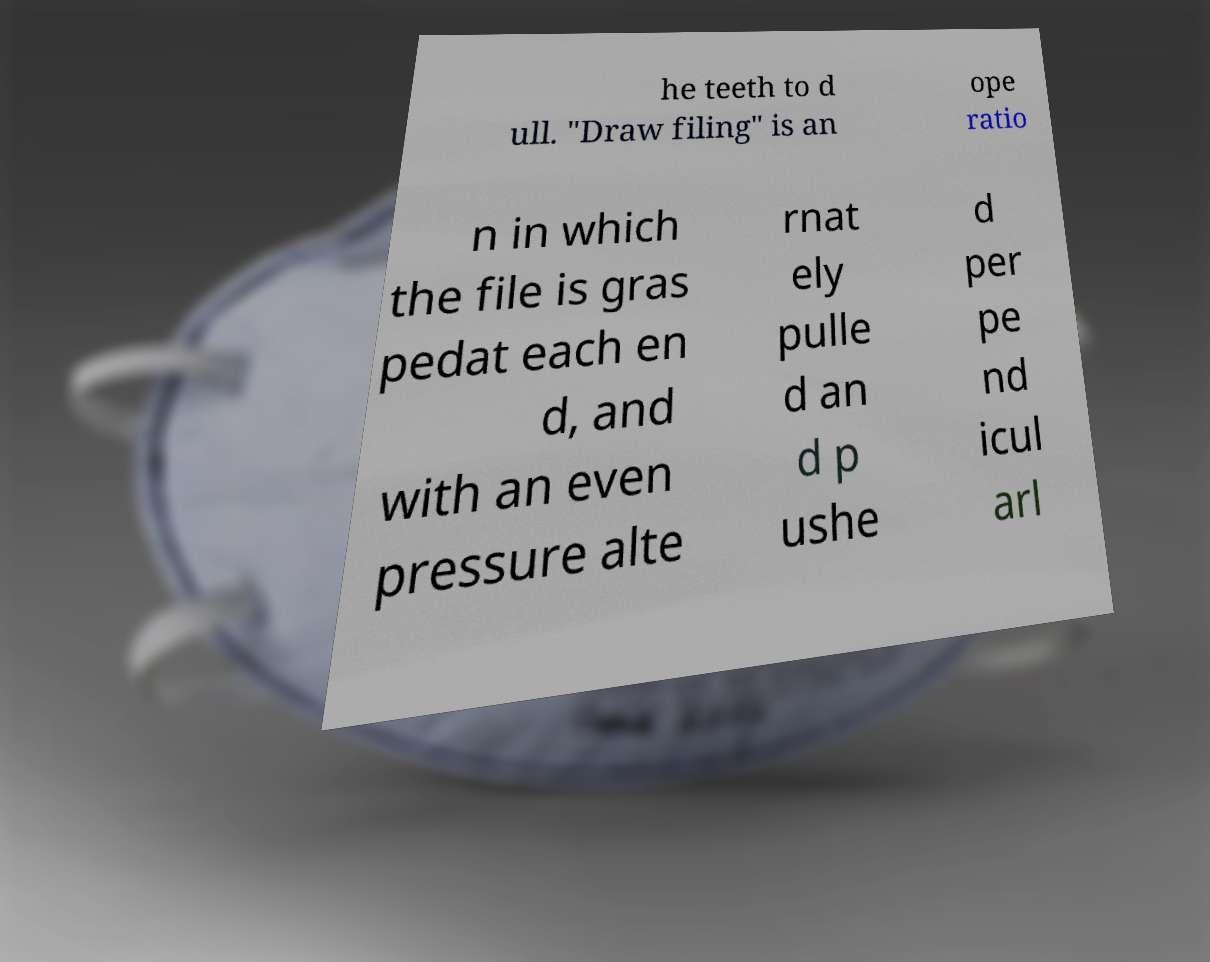Please identify and transcribe the text found in this image. he teeth to d ull. "Draw filing" is an ope ratio n in which the file is gras pedat each en d, and with an even pressure alte rnat ely pulle d an d p ushe d per pe nd icul arl 